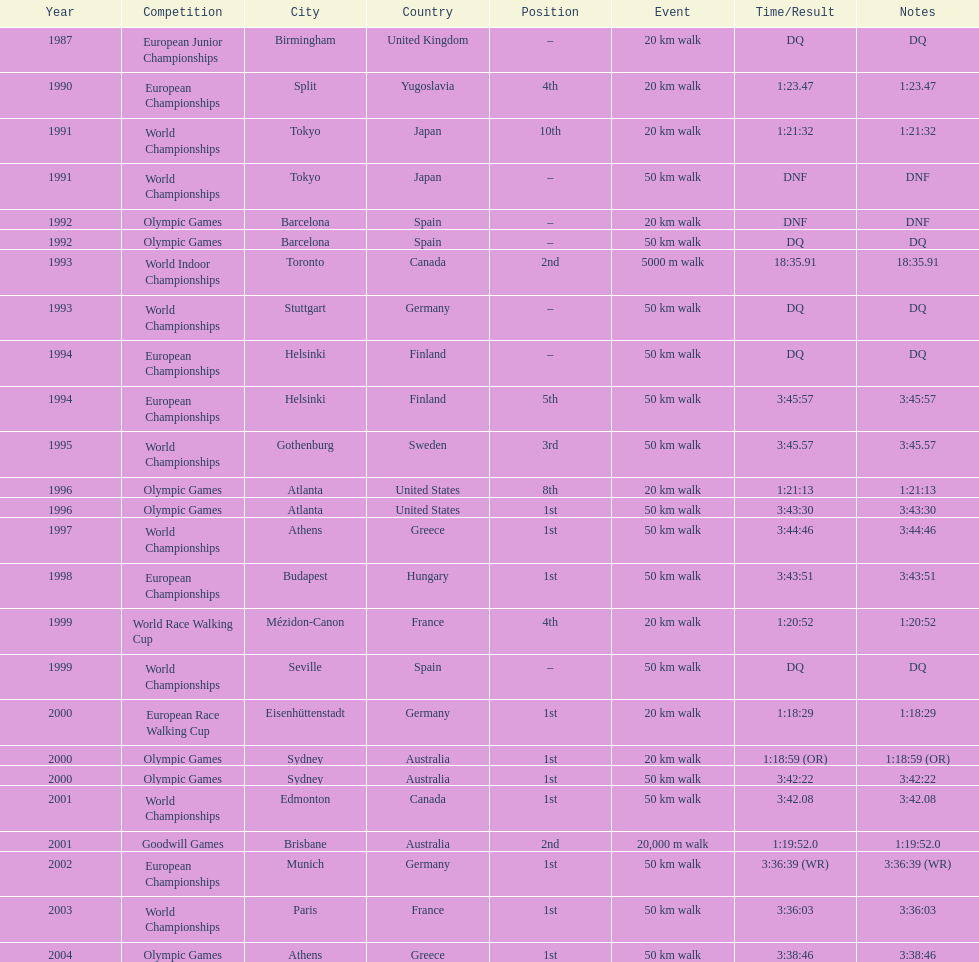What was the name of the competition that took place before the olympic games in 1996? World Championships. 